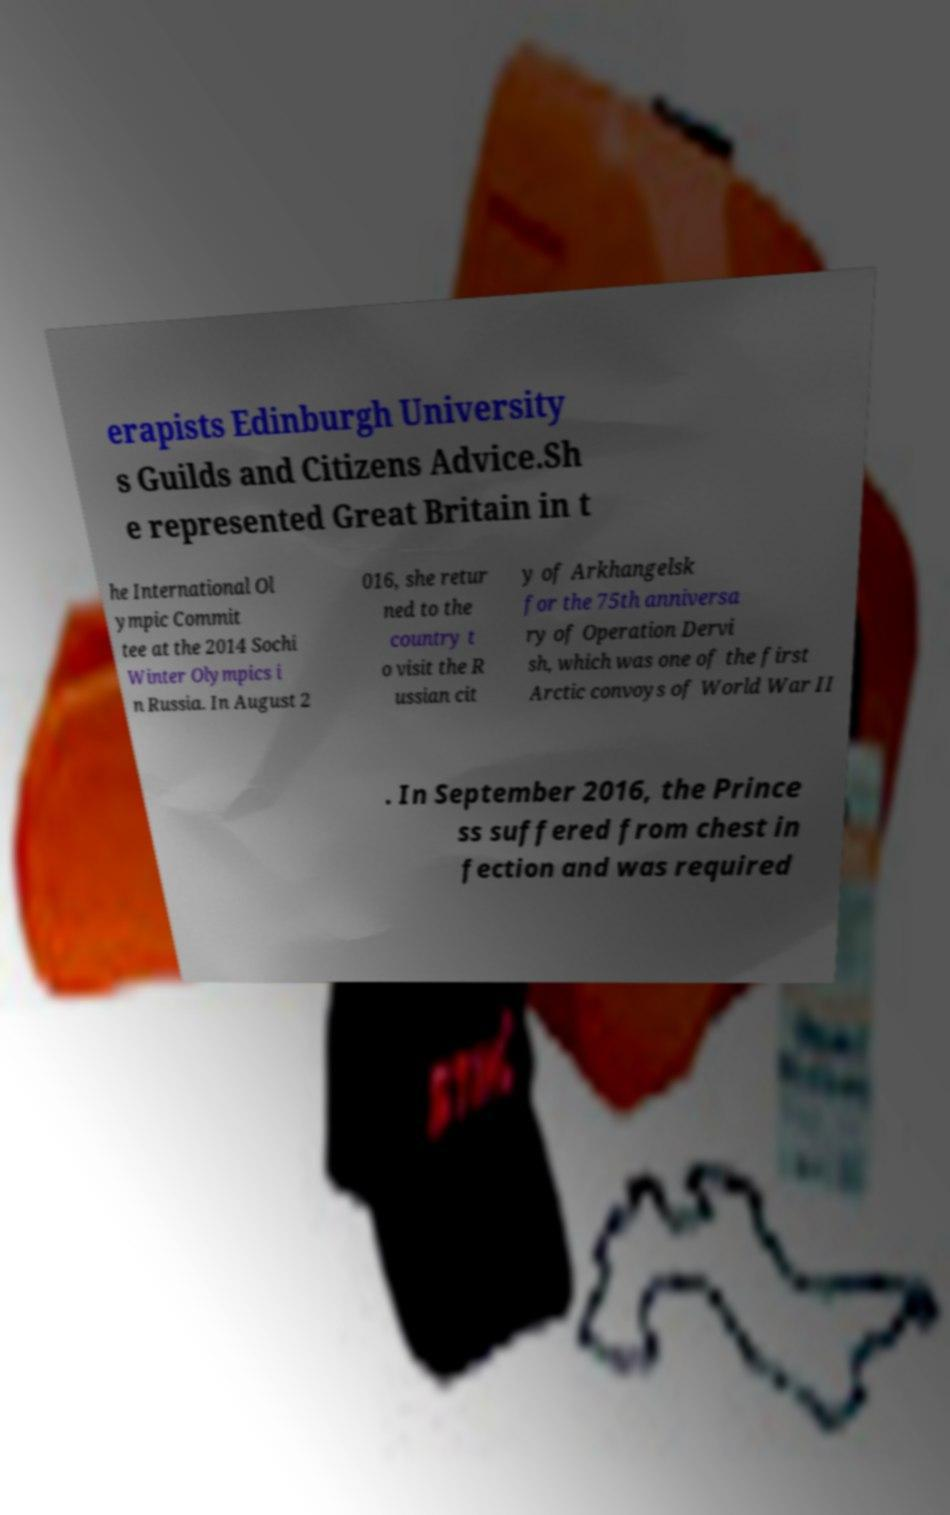Can you accurately transcribe the text from the provided image for me? erapists Edinburgh University s Guilds and Citizens Advice.Sh e represented Great Britain in t he International Ol ympic Commit tee at the 2014 Sochi Winter Olympics i n Russia. In August 2 016, she retur ned to the country t o visit the R ussian cit y of Arkhangelsk for the 75th anniversa ry of Operation Dervi sh, which was one of the first Arctic convoys of World War II . In September 2016, the Prince ss suffered from chest in fection and was required 